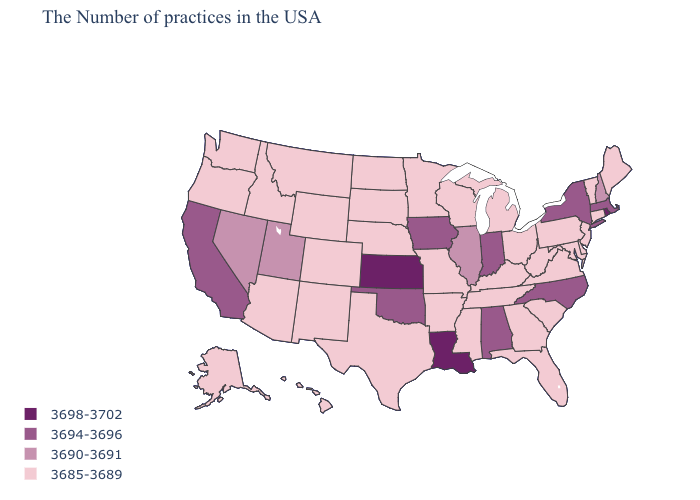Name the states that have a value in the range 3690-3691?
Concise answer only. New Hampshire, Illinois, Utah, Nevada. Does Louisiana have the highest value in the USA?
Keep it brief. Yes. What is the lowest value in the West?
Keep it brief. 3685-3689. Among the states that border Oregon , does California have the highest value?
Answer briefly. Yes. What is the lowest value in states that border Pennsylvania?
Concise answer only. 3685-3689. Name the states that have a value in the range 3698-3702?
Keep it brief. Rhode Island, Louisiana, Kansas. Does Delaware have the highest value in the USA?
Short answer required. No. Among the states that border Maryland , which have the lowest value?
Quick response, please. Delaware, Pennsylvania, Virginia, West Virginia. Does Rhode Island have the lowest value in the USA?
Quick response, please. No. Which states have the lowest value in the USA?
Concise answer only. Maine, Vermont, Connecticut, New Jersey, Delaware, Maryland, Pennsylvania, Virginia, South Carolina, West Virginia, Ohio, Florida, Georgia, Michigan, Kentucky, Tennessee, Wisconsin, Mississippi, Missouri, Arkansas, Minnesota, Nebraska, Texas, South Dakota, North Dakota, Wyoming, Colorado, New Mexico, Montana, Arizona, Idaho, Washington, Oregon, Alaska, Hawaii. Among the states that border Idaho , does Oregon have the highest value?
Quick response, please. No. Name the states that have a value in the range 3694-3696?
Quick response, please. Massachusetts, New York, North Carolina, Indiana, Alabama, Iowa, Oklahoma, California. Among the states that border Nebraska , which have the highest value?
Keep it brief. Kansas. Which states hav the highest value in the Northeast?
Short answer required. Rhode Island. Does Idaho have the lowest value in the West?
Quick response, please. Yes. 